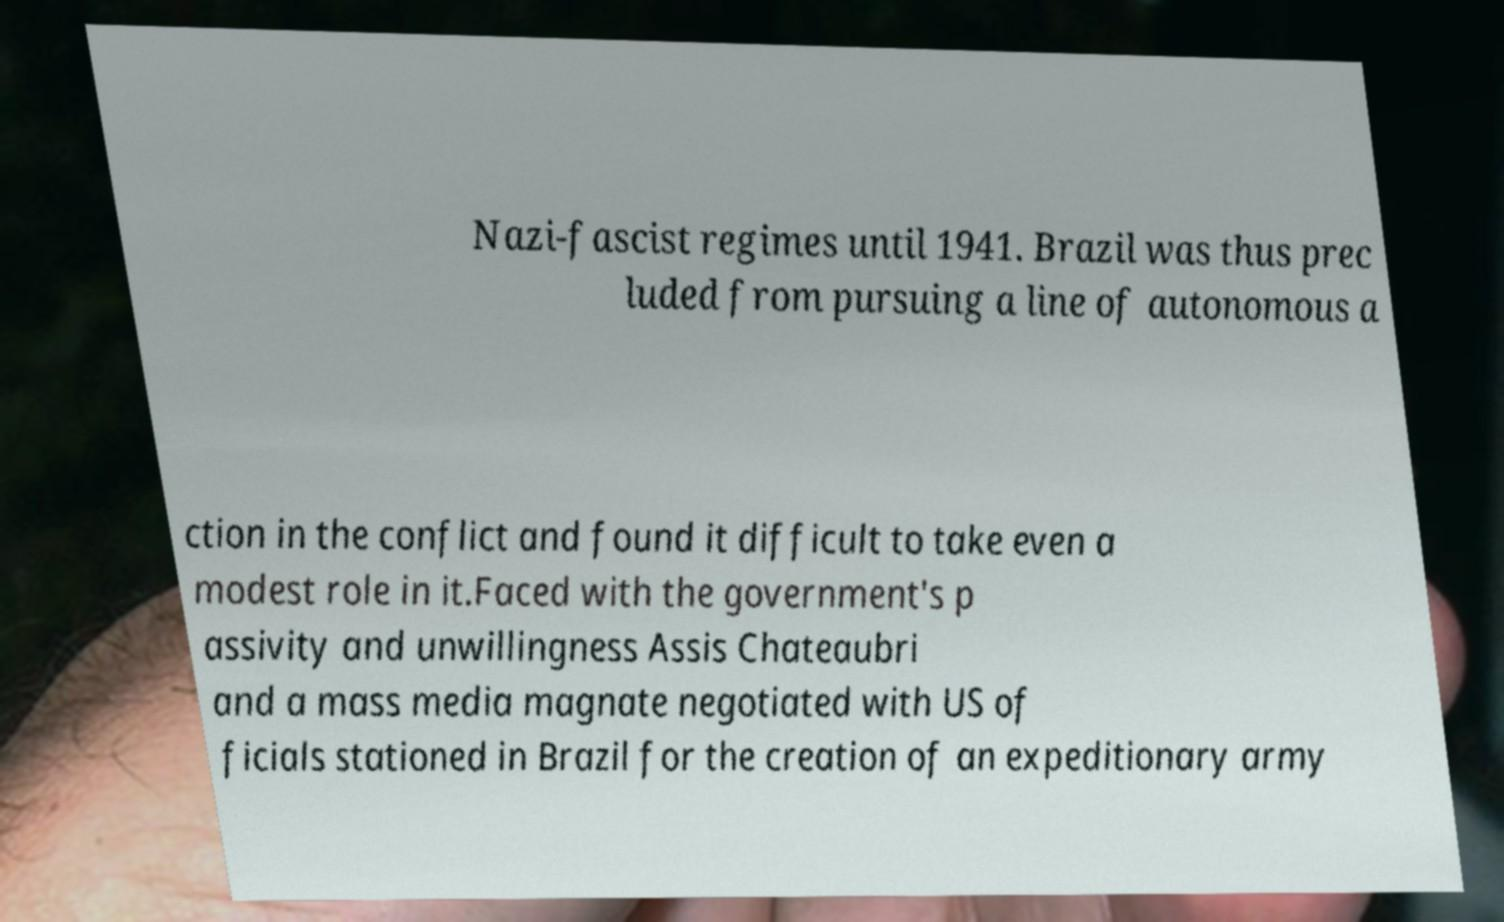Can you read and provide the text displayed in the image?This photo seems to have some interesting text. Can you extract and type it out for me? Nazi-fascist regimes until 1941. Brazil was thus prec luded from pursuing a line of autonomous a ction in the conflict and found it difficult to take even a modest role in it.Faced with the government's p assivity and unwillingness Assis Chateaubri and a mass media magnate negotiated with US of ficials stationed in Brazil for the creation of an expeditionary army 